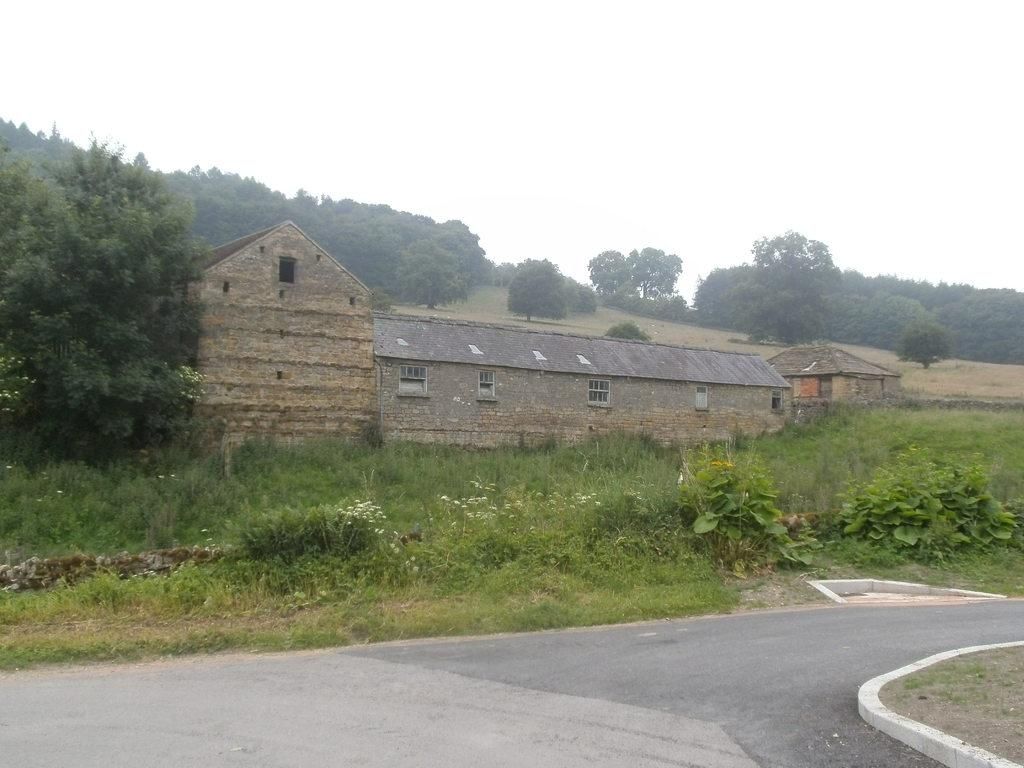What is the main feature of the image? There is a road in the image. What type of vegetation is near the road? Grass and plants are visible near the road. What structures can be seen in the image? Buildings are present in the image. What can be seen in the distance in the image? There are many trees and the sky visible in the background of the image. What type of soup is being served in the image? There is no soup present in the image; it features a road, grass, plants, buildings, trees, and the sky. 